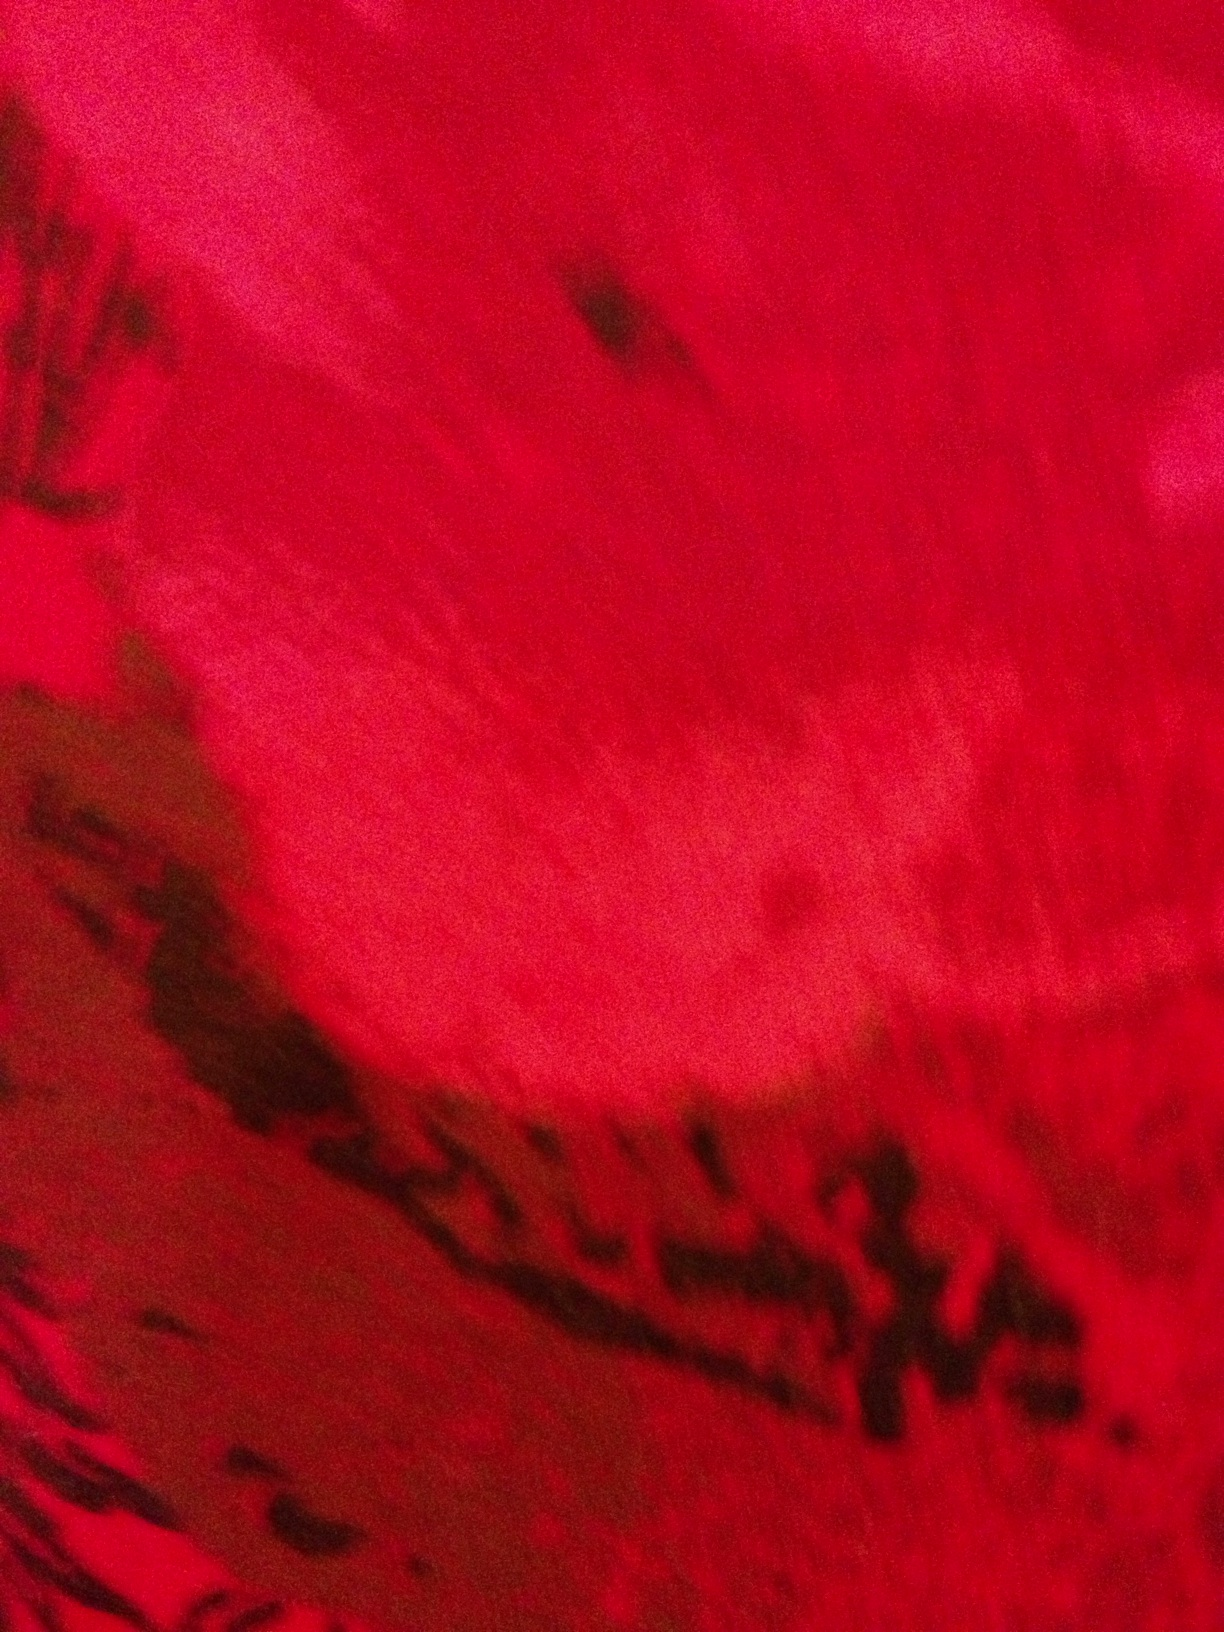Can you describe the color shades visible in this image? The image features a vivid red background with shades ranging from bright crimson to deeper maroon. There are also areas where the color darkens almost to black, providing a strong visual contrast. 